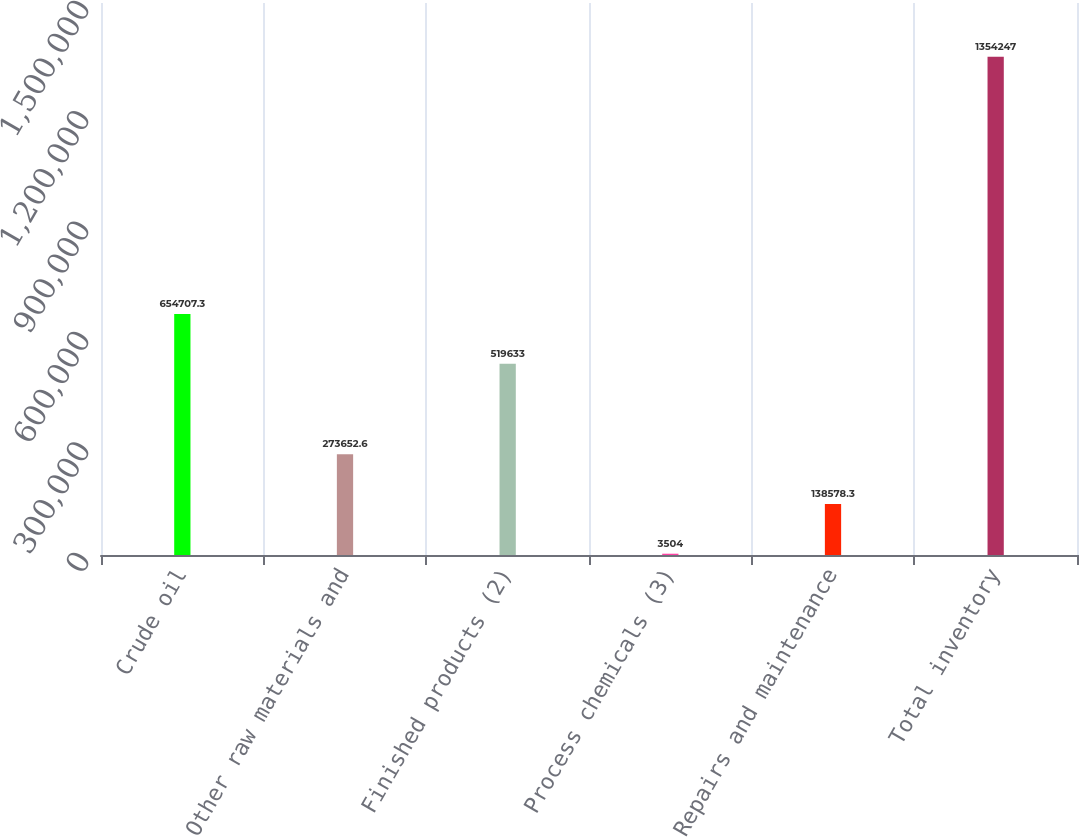<chart> <loc_0><loc_0><loc_500><loc_500><bar_chart><fcel>Crude oil<fcel>Other raw materials and<fcel>Finished products (2)<fcel>Process chemicals (3)<fcel>Repairs and maintenance<fcel>Total inventory<nl><fcel>654707<fcel>273653<fcel>519633<fcel>3504<fcel>138578<fcel>1.35425e+06<nl></chart> 